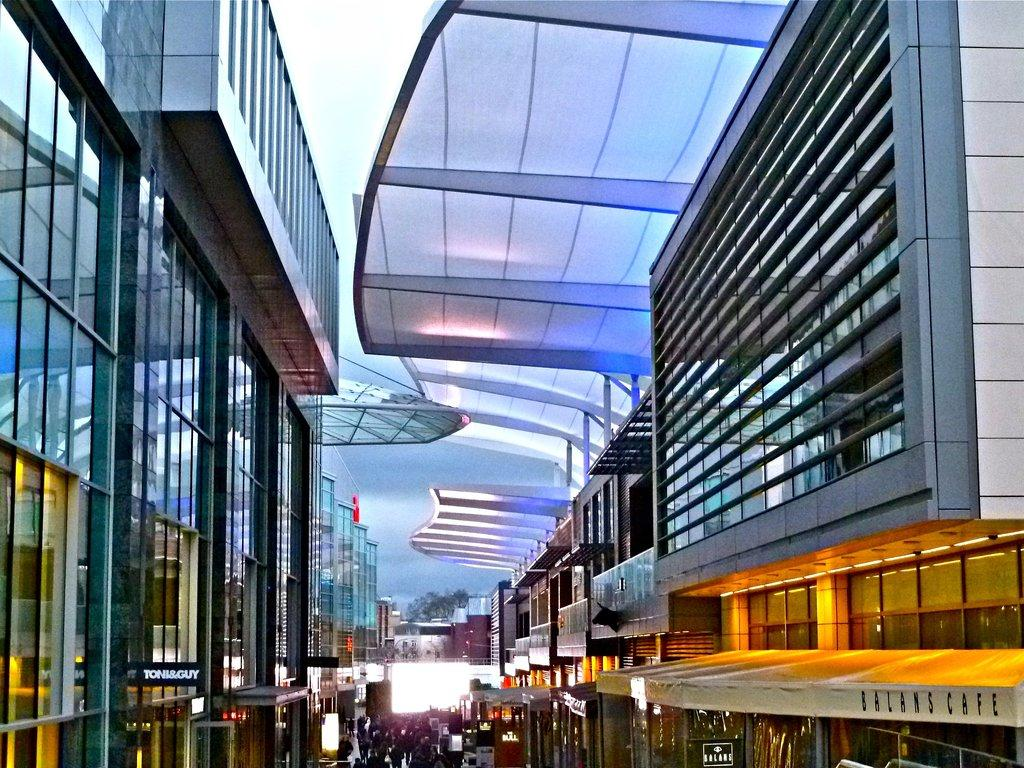What type of buildings are featured in the image? The buildings in the image have glass walls on the sides. Can you describe the people at the bottom of the image? There are people at the bottom of the image, but their specific actions or characteristics are not mentioned in the facts. What can be seen in the background of the image? The sky is visible in the background of the image. What type of garden is visible in the image? There is no garden present in the image. What type of produce can be seen growing on the buildings? There is no produce visible in the image, as the buildings have glass walls and not gardens or fields. 